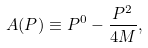<formula> <loc_0><loc_0><loc_500><loc_500>A ( P ) \equiv P ^ { 0 } - \frac { P ^ { 2 } } { 4 M } ,</formula> 